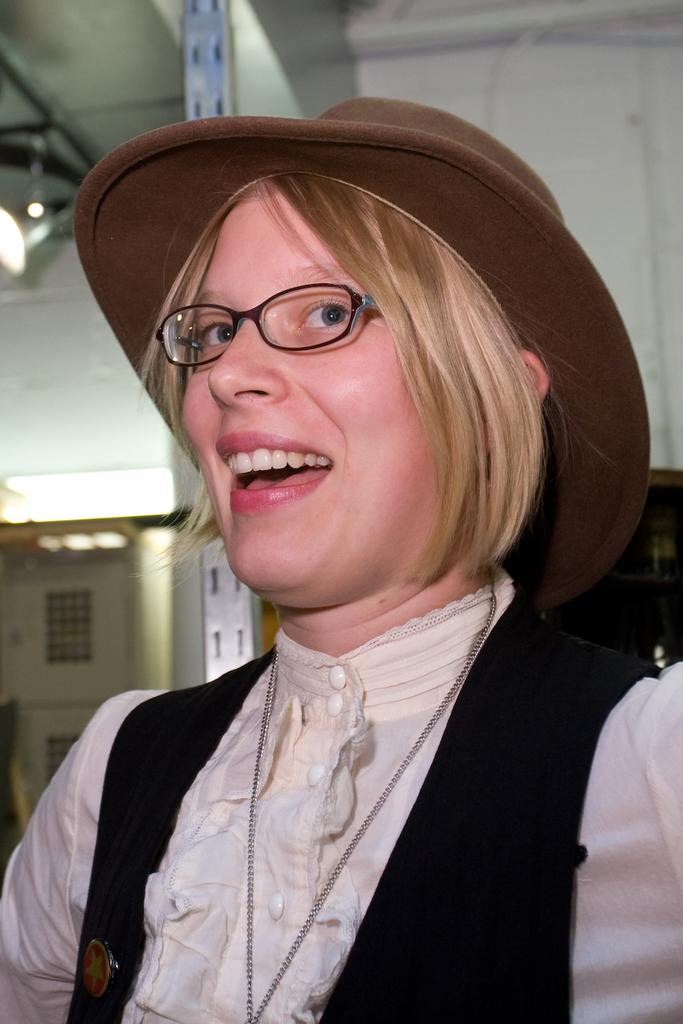Who is present in the image? There are women in the picture. What are the women wearing in the image? The women are wearing spectacles. What can be seen in the background of the image? There is light visible up to the roof in the background. What is the price of the basketball coach in the image? There is no basketball coach or price mentioned in the image; it features women wearing spectacles. 